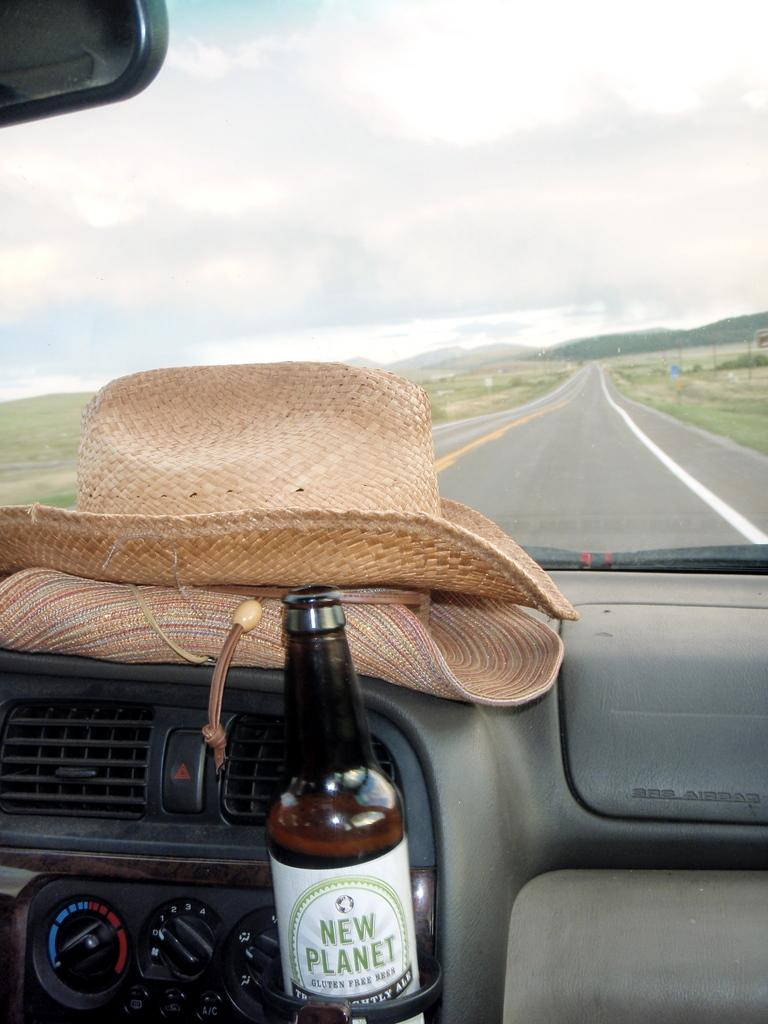What is inside the vehicle in the image? There is a bottle inside the vehicle. What can be seen outside the vehicle in the image? There is a road visible in the image. What is visible above the road in the image? The sky is visible in the image. How would you describe the sky in the image? The sky has heavy clouds in the image. What type of wool is being used to design the road in the image? There is no wool or design process visible in the image; it shows a road and a sky with heavy clouds. 